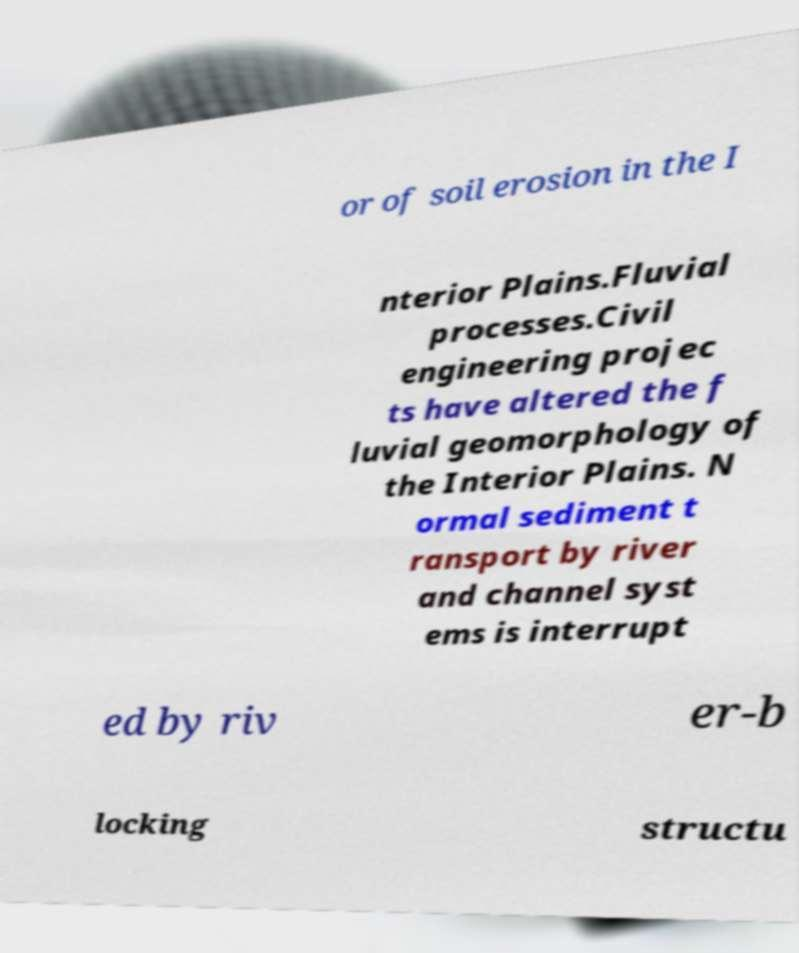Please identify and transcribe the text found in this image. or of soil erosion in the I nterior Plains.Fluvial processes.Civil engineering projec ts have altered the f luvial geomorphology of the Interior Plains. N ormal sediment t ransport by river and channel syst ems is interrupt ed by riv er-b locking structu 